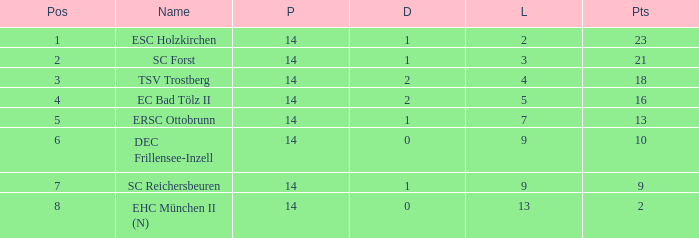Which Points have a Position larger than 6, and a Lost smaller than 13? 9.0. 